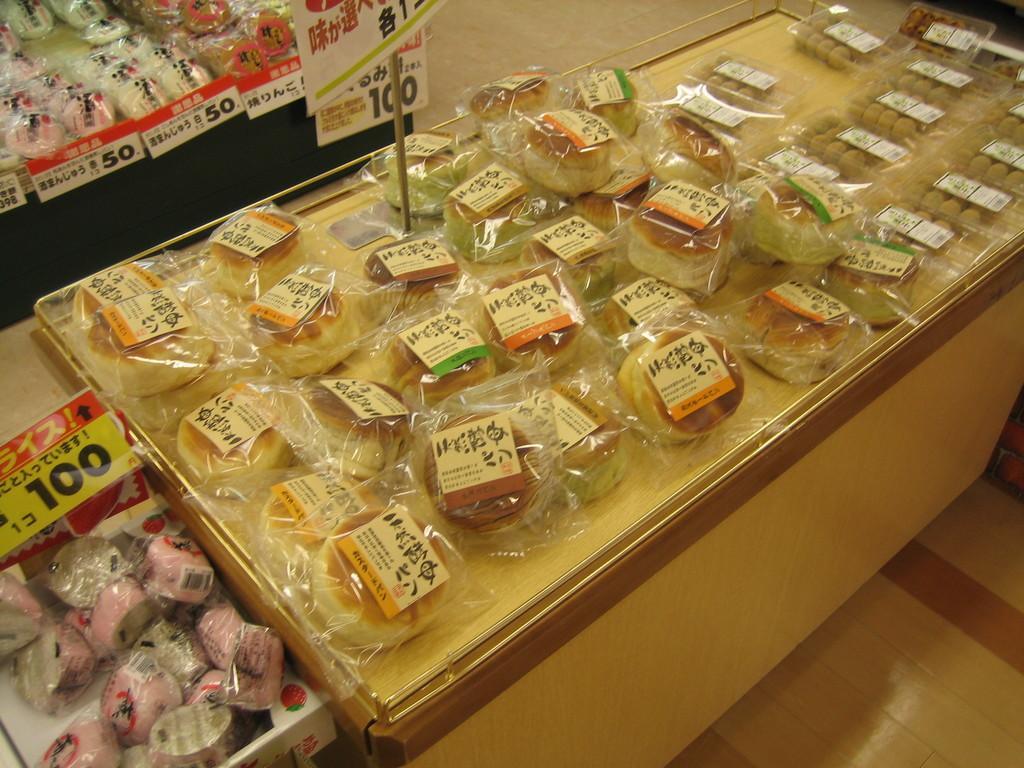Please provide a concise description of this image. In this picture we can see the tables on the top of which the packets of food items are placed and we can see the text and the numbers on the posters and we can see the text and the bar code on the papers which are attached to the packets. On the right we can see the boxes of food items and we can see the papers attached to the boxes with seems to be containing the text. In the background we can see the ground. 